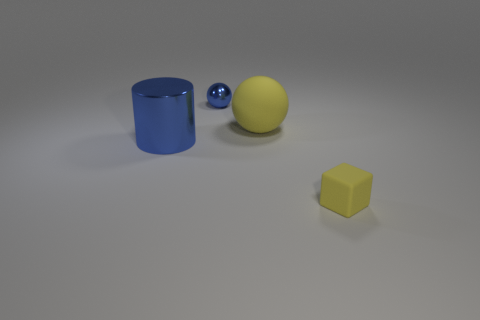Is the thing in front of the big metal cylinder made of the same material as the large cylinder?
Your answer should be compact. No. Is there any other thing that has the same size as the block?
Your answer should be very brief. Yes. There is a blue metal thing that is the same shape as the large matte object; what is its size?
Give a very brief answer. Small. Are there more tiny yellow matte things on the left side of the blue metal cylinder than blue things that are left of the tiny metal sphere?
Offer a very short reply. No. Do the yellow block and the yellow thing behind the large blue cylinder have the same material?
Your answer should be very brief. Yes. Is there any other thing that has the same shape as the tiny yellow rubber thing?
Give a very brief answer. No. What color is the object that is to the left of the large yellow ball and behind the big blue cylinder?
Your answer should be compact. Blue. The yellow rubber object that is behind the tiny matte thing has what shape?
Your answer should be compact. Sphere. There is a shiny thing that is in front of the tiny metal sphere that is behind the sphere to the right of the small blue shiny sphere; what size is it?
Keep it short and to the point. Large. How many big cylinders are behind the blue thing that is behind the large yellow object?
Your answer should be very brief. 0. 